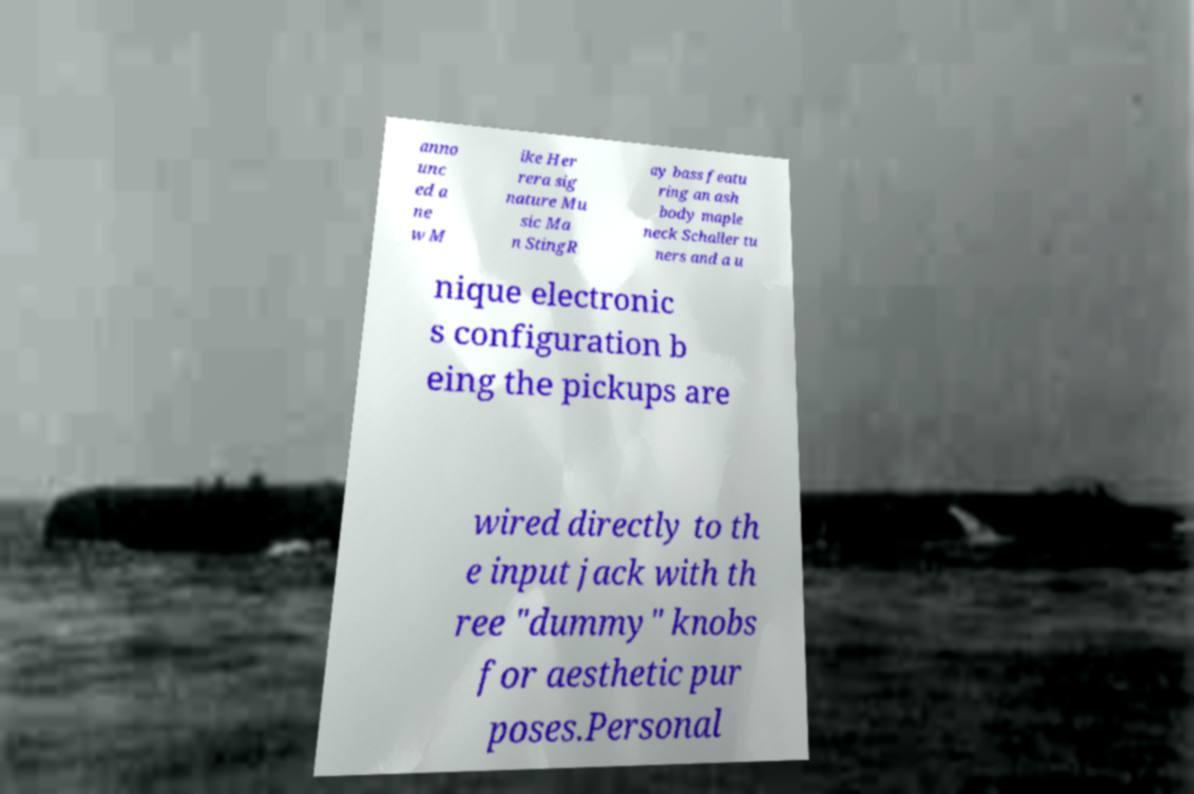Can you read and provide the text displayed in the image?This photo seems to have some interesting text. Can you extract and type it out for me? anno unc ed a ne w M ike Her rera sig nature Mu sic Ma n StingR ay bass featu ring an ash body maple neck Schaller tu ners and a u nique electronic s configuration b eing the pickups are wired directly to th e input jack with th ree "dummy" knobs for aesthetic pur poses.Personal 